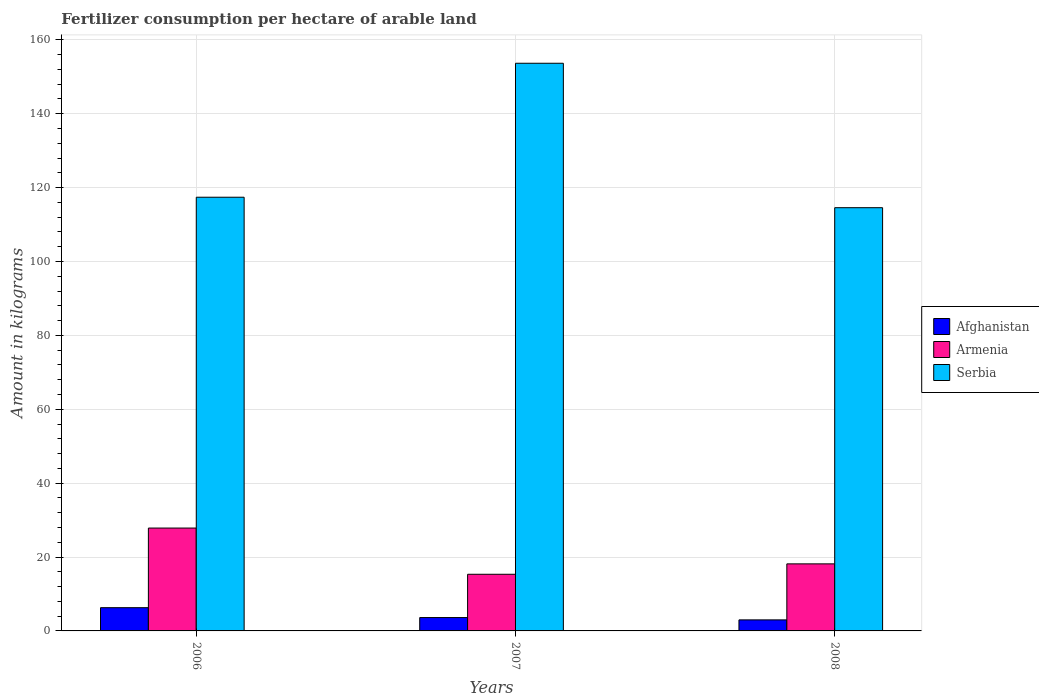What is the amount of fertilizer consumption in Afghanistan in 2007?
Give a very brief answer. 3.62. Across all years, what is the maximum amount of fertilizer consumption in Serbia?
Keep it short and to the point. 153.66. Across all years, what is the minimum amount of fertilizer consumption in Serbia?
Provide a short and direct response. 114.56. What is the total amount of fertilizer consumption in Armenia in the graph?
Provide a short and direct response. 61.33. What is the difference between the amount of fertilizer consumption in Serbia in 2006 and that in 2008?
Ensure brevity in your answer.  2.83. What is the difference between the amount of fertilizer consumption in Serbia in 2007 and the amount of fertilizer consumption in Afghanistan in 2006?
Your answer should be compact. 147.36. What is the average amount of fertilizer consumption in Armenia per year?
Your answer should be compact. 20.44. In the year 2006, what is the difference between the amount of fertilizer consumption in Armenia and amount of fertilizer consumption in Afghanistan?
Your answer should be very brief. 21.55. In how many years, is the amount of fertilizer consumption in Afghanistan greater than 132 kg?
Offer a very short reply. 0. What is the ratio of the amount of fertilizer consumption in Serbia in 2006 to that in 2008?
Ensure brevity in your answer.  1.02. What is the difference between the highest and the second highest amount of fertilizer consumption in Armenia?
Offer a very short reply. 9.69. What is the difference between the highest and the lowest amount of fertilizer consumption in Afghanistan?
Provide a succinct answer. 3.3. What does the 3rd bar from the left in 2007 represents?
Keep it short and to the point. Serbia. What does the 1st bar from the right in 2008 represents?
Offer a terse response. Serbia. Is it the case that in every year, the sum of the amount of fertilizer consumption in Armenia and amount of fertilizer consumption in Serbia is greater than the amount of fertilizer consumption in Afghanistan?
Offer a terse response. Yes. How many bars are there?
Keep it short and to the point. 9. Are all the bars in the graph horizontal?
Your response must be concise. No. Are the values on the major ticks of Y-axis written in scientific E-notation?
Your answer should be compact. No. Does the graph contain any zero values?
Give a very brief answer. No. Does the graph contain grids?
Provide a succinct answer. Yes. Where does the legend appear in the graph?
Ensure brevity in your answer.  Center right. How are the legend labels stacked?
Give a very brief answer. Vertical. What is the title of the graph?
Your answer should be compact. Fertilizer consumption per hectare of arable land. Does "Dominica" appear as one of the legend labels in the graph?
Provide a succinct answer. No. What is the label or title of the Y-axis?
Your response must be concise. Amount in kilograms. What is the Amount in kilograms of Afghanistan in 2006?
Your answer should be compact. 6.29. What is the Amount in kilograms of Armenia in 2006?
Offer a very short reply. 27.84. What is the Amount in kilograms in Serbia in 2006?
Make the answer very short. 117.39. What is the Amount in kilograms of Afghanistan in 2007?
Your answer should be compact. 3.62. What is the Amount in kilograms in Armenia in 2007?
Your response must be concise. 15.33. What is the Amount in kilograms in Serbia in 2007?
Keep it short and to the point. 153.66. What is the Amount in kilograms of Afghanistan in 2008?
Keep it short and to the point. 2.99. What is the Amount in kilograms in Armenia in 2008?
Make the answer very short. 18.15. What is the Amount in kilograms of Serbia in 2008?
Provide a succinct answer. 114.56. Across all years, what is the maximum Amount in kilograms in Afghanistan?
Your response must be concise. 6.29. Across all years, what is the maximum Amount in kilograms of Armenia?
Your answer should be very brief. 27.84. Across all years, what is the maximum Amount in kilograms in Serbia?
Offer a terse response. 153.66. Across all years, what is the minimum Amount in kilograms of Afghanistan?
Your answer should be very brief. 2.99. Across all years, what is the minimum Amount in kilograms in Armenia?
Provide a succinct answer. 15.33. Across all years, what is the minimum Amount in kilograms of Serbia?
Give a very brief answer. 114.56. What is the total Amount in kilograms in Afghanistan in the graph?
Make the answer very short. 12.9. What is the total Amount in kilograms of Armenia in the graph?
Provide a succinct answer. 61.33. What is the total Amount in kilograms of Serbia in the graph?
Your answer should be compact. 385.6. What is the difference between the Amount in kilograms of Afghanistan in 2006 and that in 2007?
Your response must be concise. 2.67. What is the difference between the Amount in kilograms of Armenia in 2006 and that in 2007?
Provide a short and direct response. 12.51. What is the difference between the Amount in kilograms in Serbia in 2006 and that in 2007?
Make the answer very short. -36.26. What is the difference between the Amount in kilograms in Afghanistan in 2006 and that in 2008?
Make the answer very short. 3.3. What is the difference between the Amount in kilograms of Armenia in 2006 and that in 2008?
Keep it short and to the point. 9.69. What is the difference between the Amount in kilograms in Serbia in 2006 and that in 2008?
Provide a succinct answer. 2.83. What is the difference between the Amount in kilograms in Afghanistan in 2007 and that in 2008?
Give a very brief answer. 0.63. What is the difference between the Amount in kilograms of Armenia in 2007 and that in 2008?
Keep it short and to the point. -2.82. What is the difference between the Amount in kilograms in Serbia in 2007 and that in 2008?
Make the answer very short. 39.1. What is the difference between the Amount in kilograms of Afghanistan in 2006 and the Amount in kilograms of Armenia in 2007?
Your answer should be very brief. -9.04. What is the difference between the Amount in kilograms in Afghanistan in 2006 and the Amount in kilograms in Serbia in 2007?
Make the answer very short. -147.36. What is the difference between the Amount in kilograms of Armenia in 2006 and the Amount in kilograms of Serbia in 2007?
Provide a short and direct response. -125.81. What is the difference between the Amount in kilograms in Afghanistan in 2006 and the Amount in kilograms in Armenia in 2008?
Offer a very short reply. -11.86. What is the difference between the Amount in kilograms in Afghanistan in 2006 and the Amount in kilograms in Serbia in 2008?
Make the answer very short. -108.27. What is the difference between the Amount in kilograms of Armenia in 2006 and the Amount in kilograms of Serbia in 2008?
Provide a succinct answer. -86.71. What is the difference between the Amount in kilograms in Afghanistan in 2007 and the Amount in kilograms in Armenia in 2008?
Your answer should be very brief. -14.53. What is the difference between the Amount in kilograms in Afghanistan in 2007 and the Amount in kilograms in Serbia in 2008?
Your response must be concise. -110.94. What is the difference between the Amount in kilograms of Armenia in 2007 and the Amount in kilograms of Serbia in 2008?
Keep it short and to the point. -99.22. What is the average Amount in kilograms in Afghanistan per year?
Your response must be concise. 4.3. What is the average Amount in kilograms in Armenia per year?
Ensure brevity in your answer.  20.44. What is the average Amount in kilograms of Serbia per year?
Your answer should be very brief. 128.53. In the year 2006, what is the difference between the Amount in kilograms in Afghanistan and Amount in kilograms in Armenia?
Keep it short and to the point. -21.55. In the year 2006, what is the difference between the Amount in kilograms in Afghanistan and Amount in kilograms in Serbia?
Your answer should be very brief. -111.1. In the year 2006, what is the difference between the Amount in kilograms in Armenia and Amount in kilograms in Serbia?
Your response must be concise. -89.55. In the year 2007, what is the difference between the Amount in kilograms of Afghanistan and Amount in kilograms of Armenia?
Provide a short and direct response. -11.71. In the year 2007, what is the difference between the Amount in kilograms of Afghanistan and Amount in kilograms of Serbia?
Make the answer very short. -150.04. In the year 2007, what is the difference between the Amount in kilograms in Armenia and Amount in kilograms in Serbia?
Offer a very short reply. -138.32. In the year 2008, what is the difference between the Amount in kilograms in Afghanistan and Amount in kilograms in Armenia?
Provide a succinct answer. -15.16. In the year 2008, what is the difference between the Amount in kilograms of Afghanistan and Amount in kilograms of Serbia?
Your answer should be very brief. -111.57. In the year 2008, what is the difference between the Amount in kilograms in Armenia and Amount in kilograms in Serbia?
Keep it short and to the point. -96.41. What is the ratio of the Amount in kilograms in Afghanistan in 2006 to that in 2007?
Make the answer very short. 1.74. What is the ratio of the Amount in kilograms of Armenia in 2006 to that in 2007?
Ensure brevity in your answer.  1.82. What is the ratio of the Amount in kilograms in Serbia in 2006 to that in 2007?
Make the answer very short. 0.76. What is the ratio of the Amount in kilograms of Afghanistan in 2006 to that in 2008?
Your answer should be compact. 2.11. What is the ratio of the Amount in kilograms of Armenia in 2006 to that in 2008?
Your answer should be compact. 1.53. What is the ratio of the Amount in kilograms of Serbia in 2006 to that in 2008?
Provide a succinct answer. 1.02. What is the ratio of the Amount in kilograms of Afghanistan in 2007 to that in 2008?
Offer a terse response. 1.21. What is the ratio of the Amount in kilograms in Armenia in 2007 to that in 2008?
Give a very brief answer. 0.84. What is the ratio of the Amount in kilograms of Serbia in 2007 to that in 2008?
Give a very brief answer. 1.34. What is the difference between the highest and the second highest Amount in kilograms in Afghanistan?
Your response must be concise. 2.67. What is the difference between the highest and the second highest Amount in kilograms of Armenia?
Your answer should be compact. 9.69. What is the difference between the highest and the second highest Amount in kilograms in Serbia?
Ensure brevity in your answer.  36.26. What is the difference between the highest and the lowest Amount in kilograms of Afghanistan?
Give a very brief answer. 3.3. What is the difference between the highest and the lowest Amount in kilograms in Armenia?
Ensure brevity in your answer.  12.51. What is the difference between the highest and the lowest Amount in kilograms of Serbia?
Ensure brevity in your answer.  39.1. 